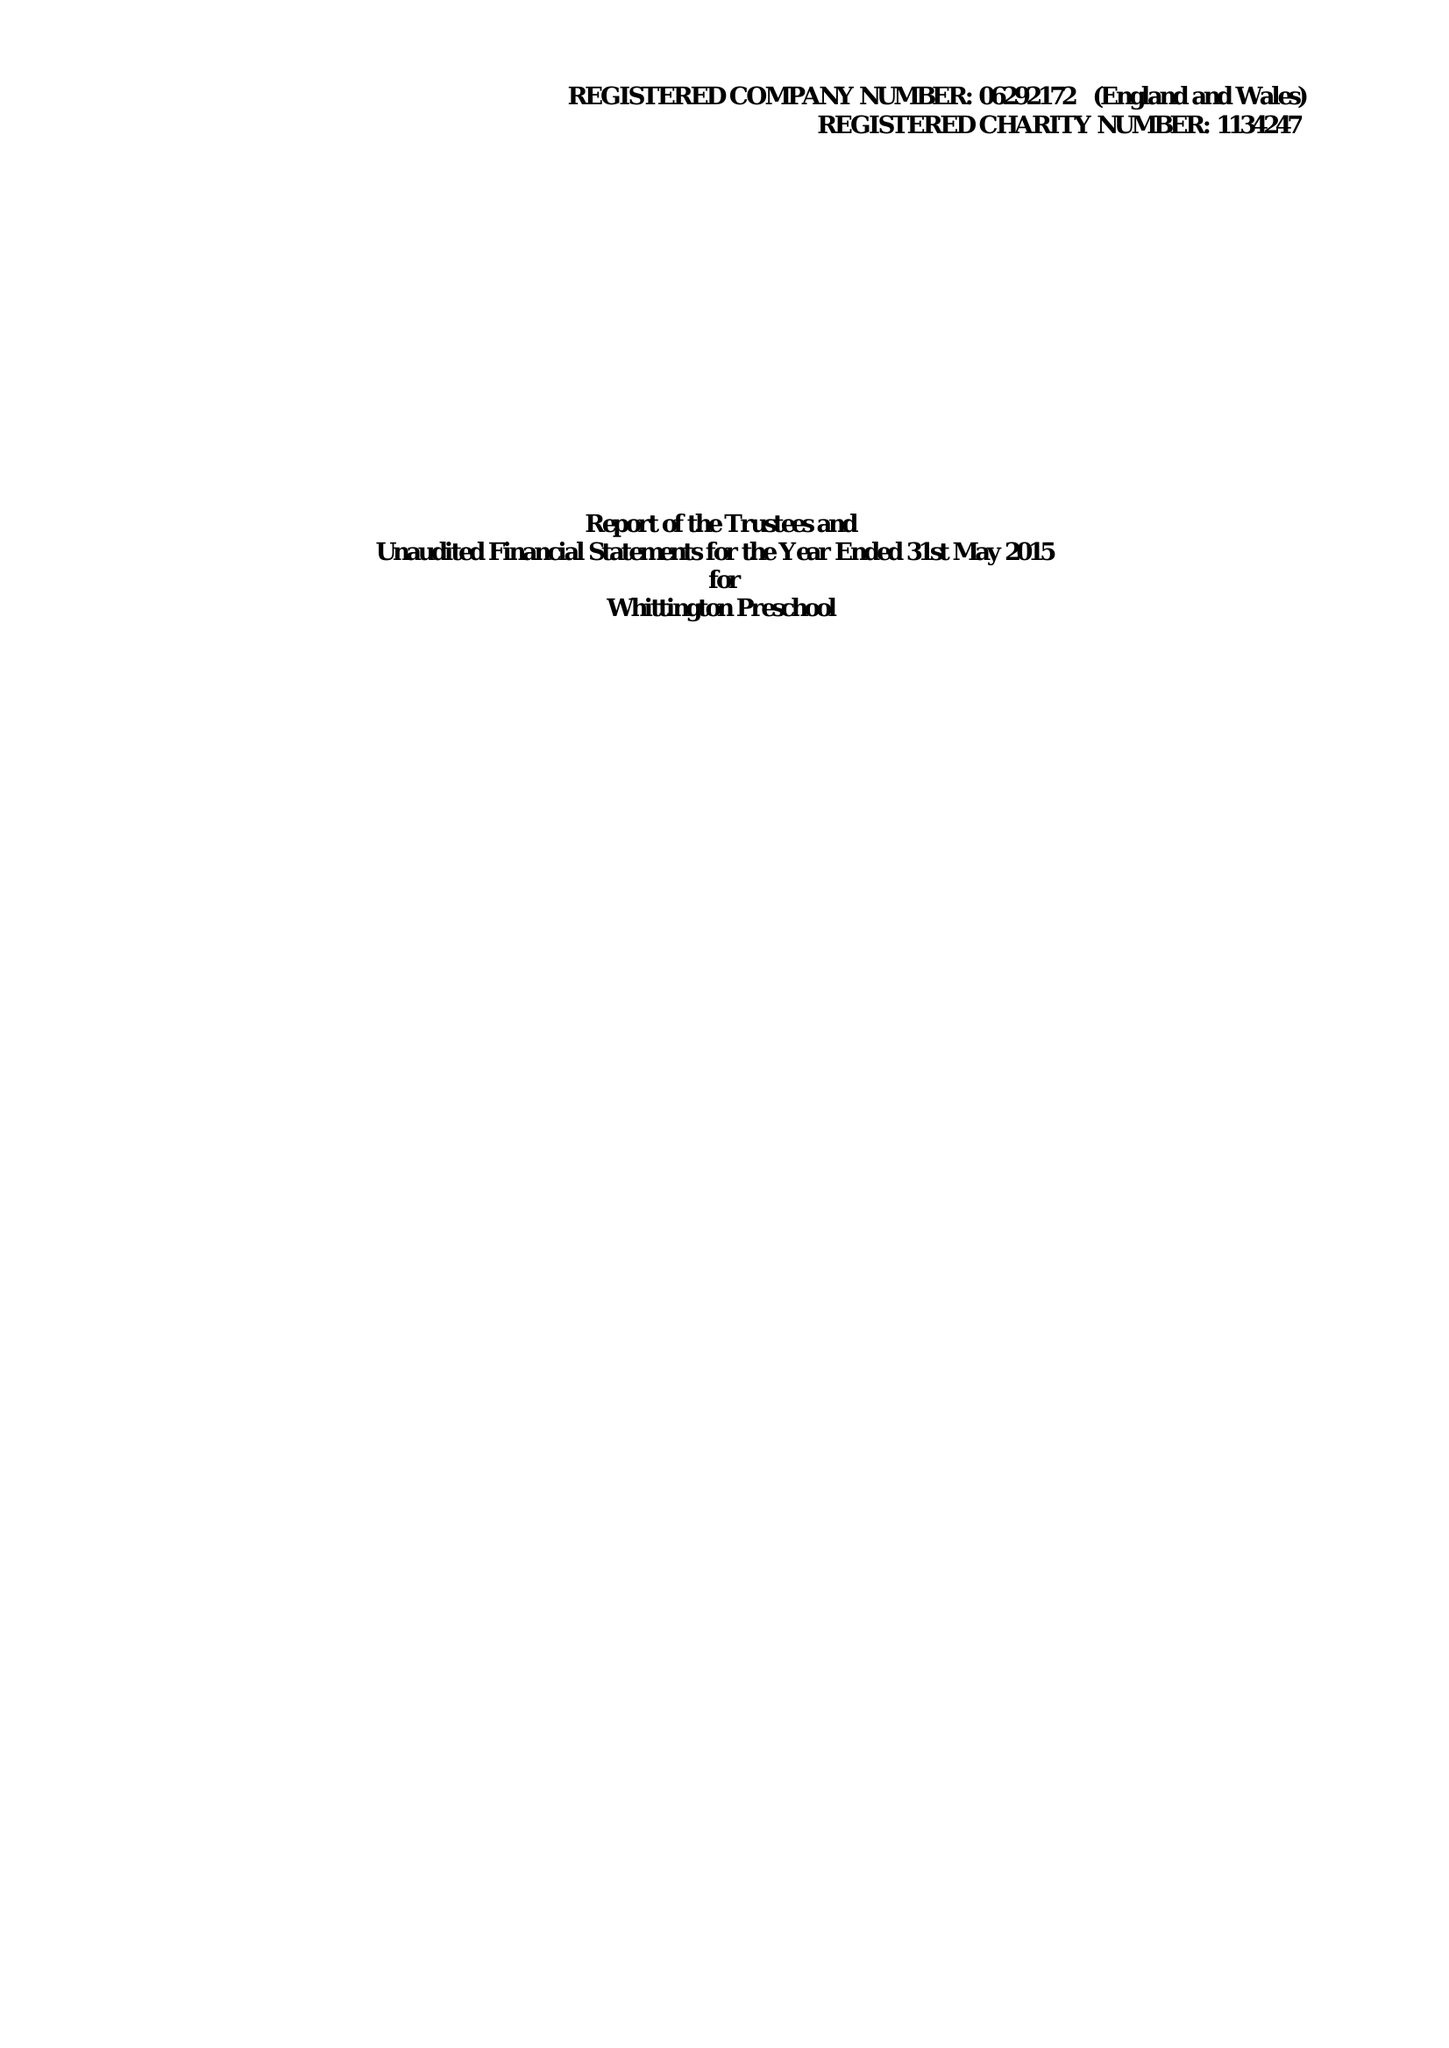What is the value for the address__post_town?
Answer the question using a single word or phrase. LICHFIELD 